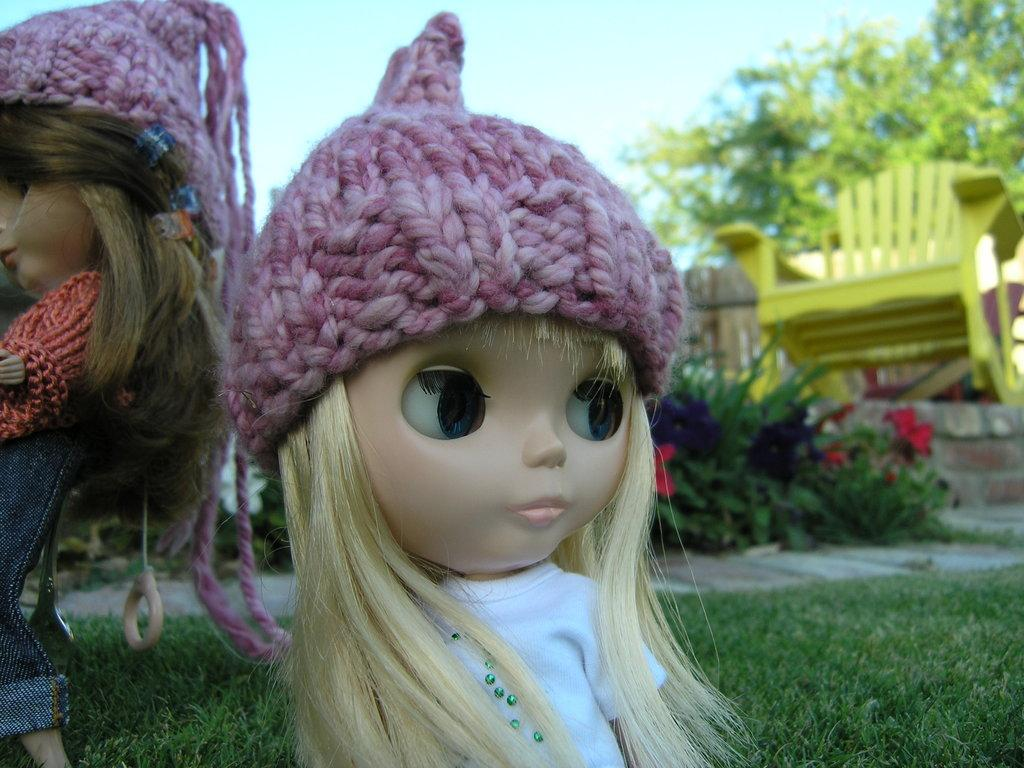What type of toys are in the image? There are dolls in the image. What can be seen on the dolls' heads? The dolls have pink caps on their heads. What type of natural environment is visible in the background of the image? There is grass, plants, a tree, and the sky visible in the background of the image. What type of furniture can be seen in the background of the image? There is a yellow chair in the background of the image. What type of trail can be seen in the image? There is no trail visible in the image; it features dolls with pink caps and a background with grass, plants, a tree, a yellow chair, and the sky. 